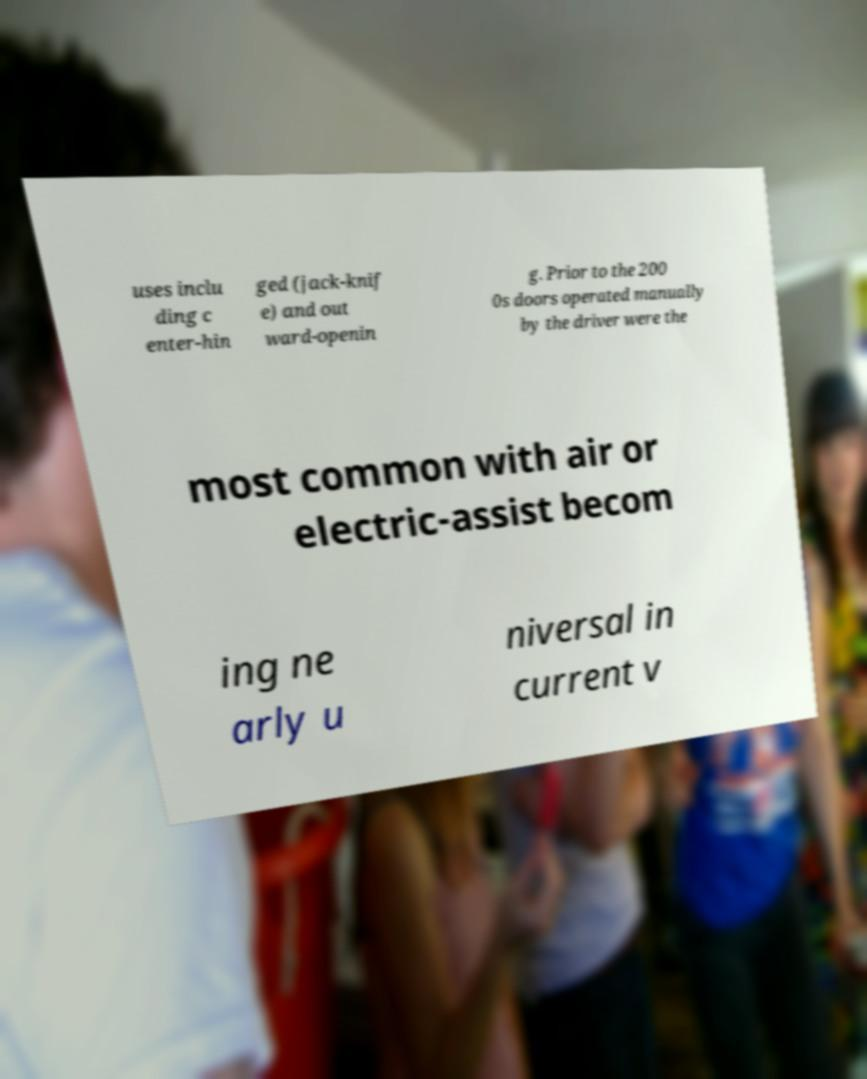Can you read and provide the text displayed in the image?This photo seems to have some interesting text. Can you extract and type it out for me? uses inclu ding c enter-hin ged (jack-knif e) and out ward-openin g. Prior to the 200 0s doors operated manually by the driver were the most common with air or electric-assist becom ing ne arly u niversal in current v 